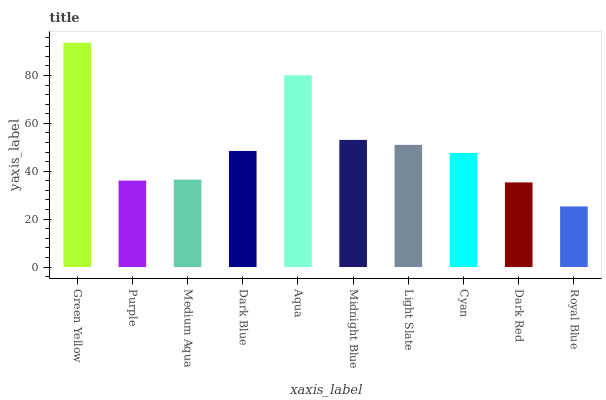Is Royal Blue the minimum?
Answer yes or no. Yes. Is Green Yellow the maximum?
Answer yes or no. Yes. Is Purple the minimum?
Answer yes or no. No. Is Purple the maximum?
Answer yes or no. No. Is Green Yellow greater than Purple?
Answer yes or no. Yes. Is Purple less than Green Yellow?
Answer yes or no. Yes. Is Purple greater than Green Yellow?
Answer yes or no. No. Is Green Yellow less than Purple?
Answer yes or no. No. Is Dark Blue the high median?
Answer yes or no. Yes. Is Cyan the low median?
Answer yes or no. Yes. Is Aqua the high median?
Answer yes or no. No. Is Green Yellow the low median?
Answer yes or no. No. 